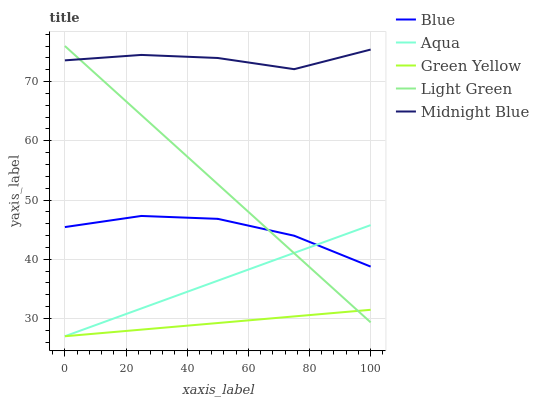Does Green Yellow have the minimum area under the curve?
Answer yes or no. Yes. Does Midnight Blue have the maximum area under the curve?
Answer yes or no. Yes. Does Aqua have the minimum area under the curve?
Answer yes or no. No. Does Aqua have the maximum area under the curve?
Answer yes or no. No. Is Green Yellow the smoothest?
Answer yes or no. Yes. Is Midnight Blue the roughest?
Answer yes or no. Yes. Is Midnight Blue the smoothest?
Answer yes or no. No. Is Aqua the roughest?
Answer yes or no. No. Does Midnight Blue have the lowest value?
Answer yes or no. No. Does Light Green have the highest value?
Answer yes or no. Yes. Does Aqua have the highest value?
Answer yes or no. No. Is Aqua less than Midnight Blue?
Answer yes or no. Yes. Is Midnight Blue greater than Blue?
Answer yes or no. Yes. Does Blue intersect Aqua?
Answer yes or no. Yes. Is Blue less than Aqua?
Answer yes or no. No. Is Blue greater than Aqua?
Answer yes or no. No. Does Aqua intersect Midnight Blue?
Answer yes or no. No. 